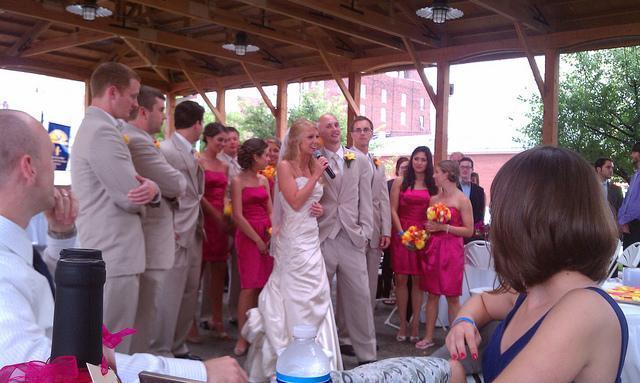How many people are there?
Give a very brief answer. 11. 